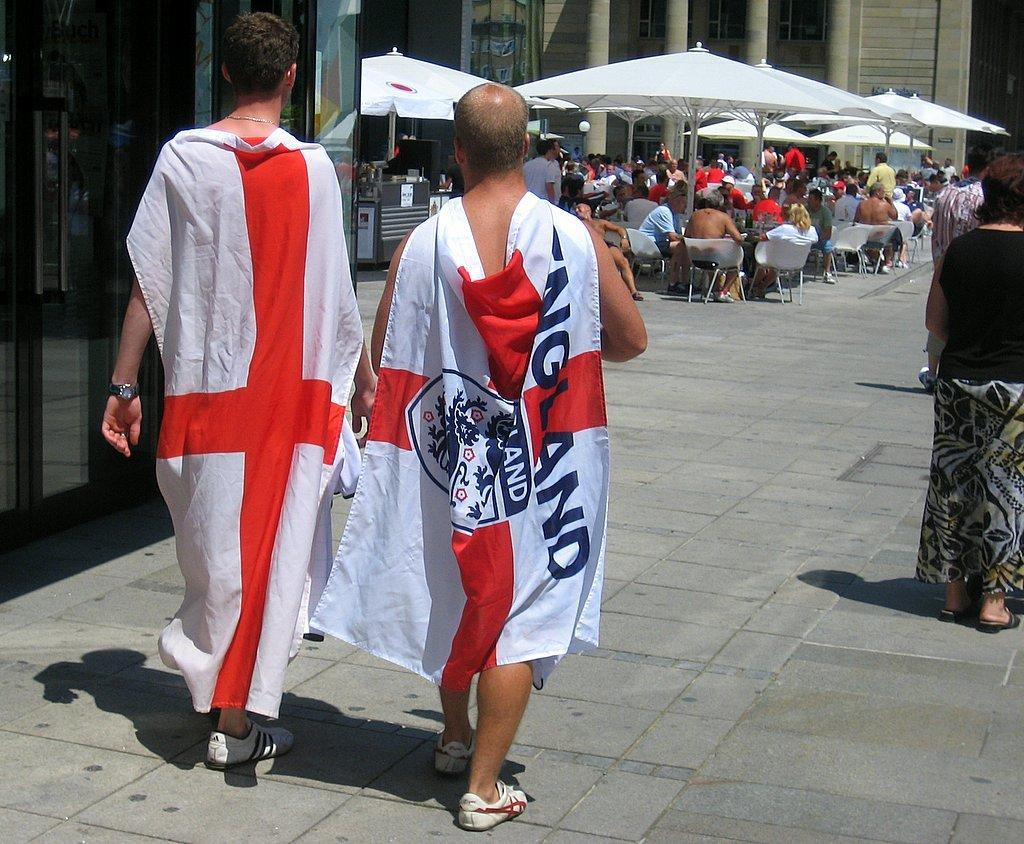<image>
Summarize the visual content of the image. Two men walking on the street with a flag draped on them that has england in black on it. 